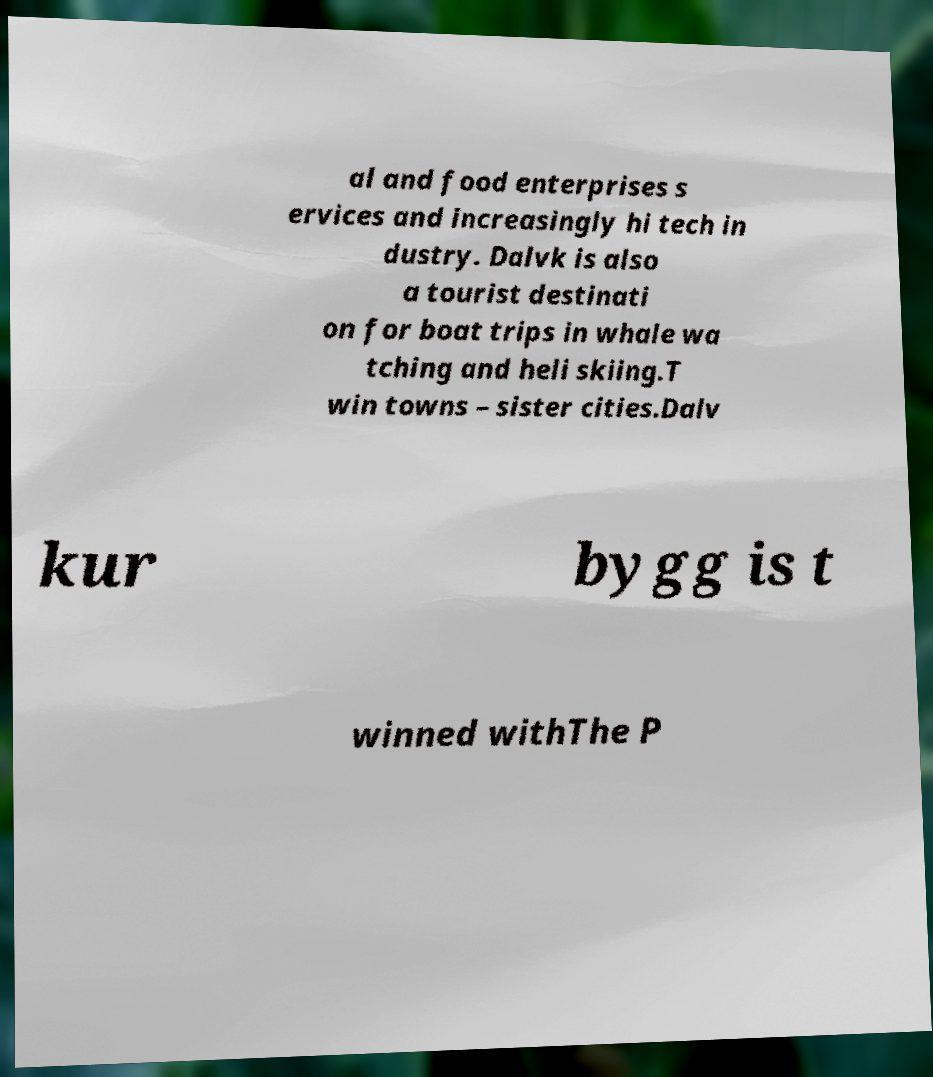What messages or text are displayed in this image? I need them in a readable, typed format. al and food enterprises s ervices and increasingly hi tech in dustry. Dalvk is also a tourist destinati on for boat trips in whale wa tching and heli skiing.T win towns – sister cities.Dalv kur bygg is t winned withThe P 